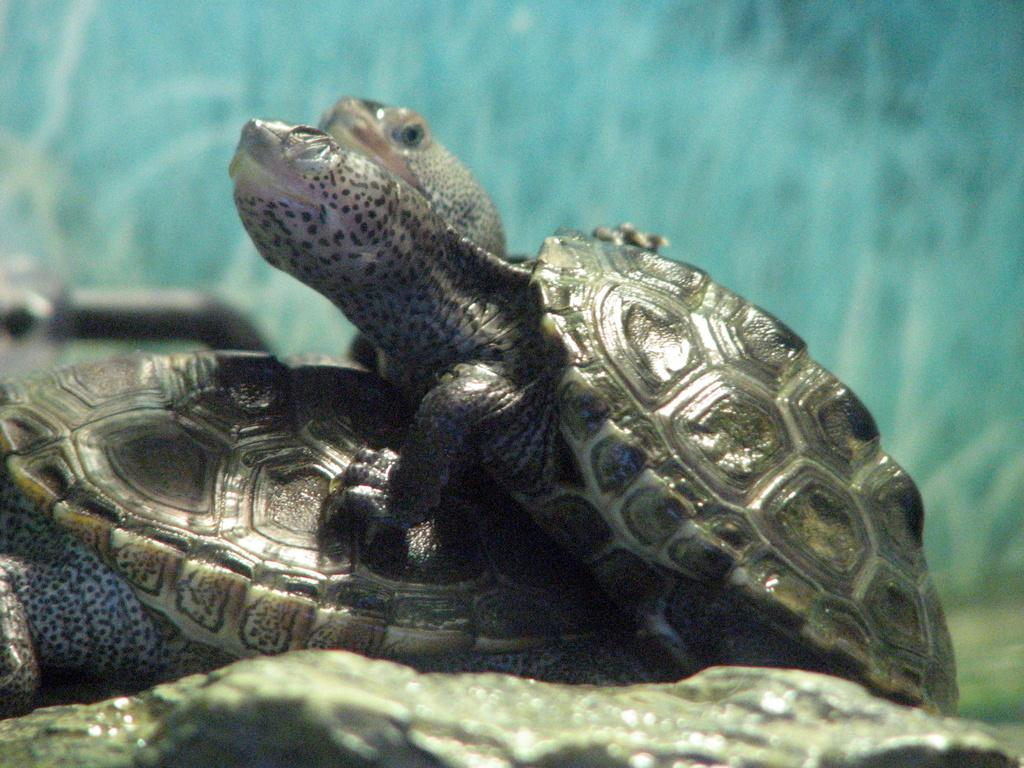How many tortoises are in the image? There are two tortoises in the image. What can be seen in the background of the image? There is a wall in the background of the image. What is located on the left side of the image? There is a black pipe on the left side of the image. How far away is the woman from the tortoises in the image? There is no woman present in the image, so it is not possible to determine the distance between her and the tortoises. 